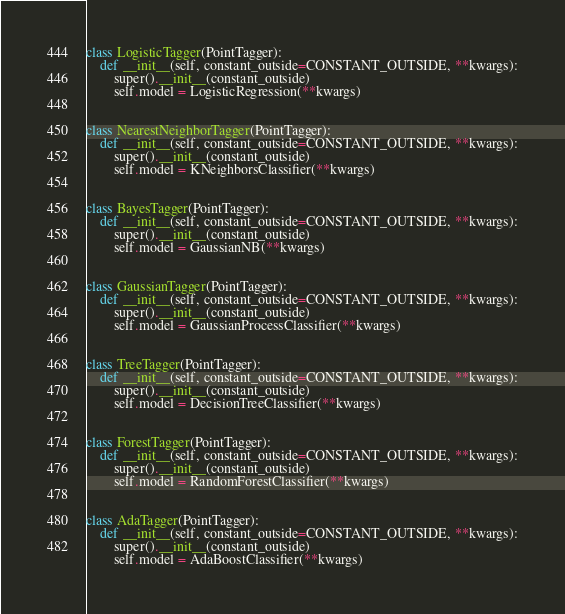<code> <loc_0><loc_0><loc_500><loc_500><_Python_>

class LogisticTagger(PointTagger):
    def __init__(self, constant_outside=CONSTANT_OUTSIDE, **kwargs):
        super().__init__(constant_outside)
        self.model = LogisticRegression(**kwargs)


class NearestNeighborTagger(PointTagger):
    def __init__(self, constant_outside=CONSTANT_OUTSIDE, **kwargs):
        super().__init__(constant_outside)
        self.model = KNeighborsClassifier(**kwargs)


class BayesTagger(PointTagger):
    def __init__(self, constant_outside=CONSTANT_OUTSIDE, **kwargs):
        super().__init__(constant_outside)
        self.model = GaussianNB(**kwargs)


class GaussianTagger(PointTagger):
    def __init__(self, constant_outside=CONSTANT_OUTSIDE, **kwargs):
        super().__init__(constant_outside)
        self.model = GaussianProcessClassifier(**kwargs)


class TreeTagger(PointTagger):
    def __init__(self, constant_outside=CONSTANT_OUTSIDE, **kwargs):
        super().__init__(constant_outside)
        self.model = DecisionTreeClassifier(**kwargs)


class ForestTagger(PointTagger):
    def __init__(self, constant_outside=CONSTANT_OUTSIDE, **kwargs):
        super().__init__(constant_outside)
        self.model = RandomForestClassifier(**kwargs)


class AdaTagger(PointTagger):
    def __init__(self, constant_outside=CONSTANT_OUTSIDE, **kwargs):
        super().__init__(constant_outside)
        self.model = AdaBoostClassifier(**kwargs)
</code> 